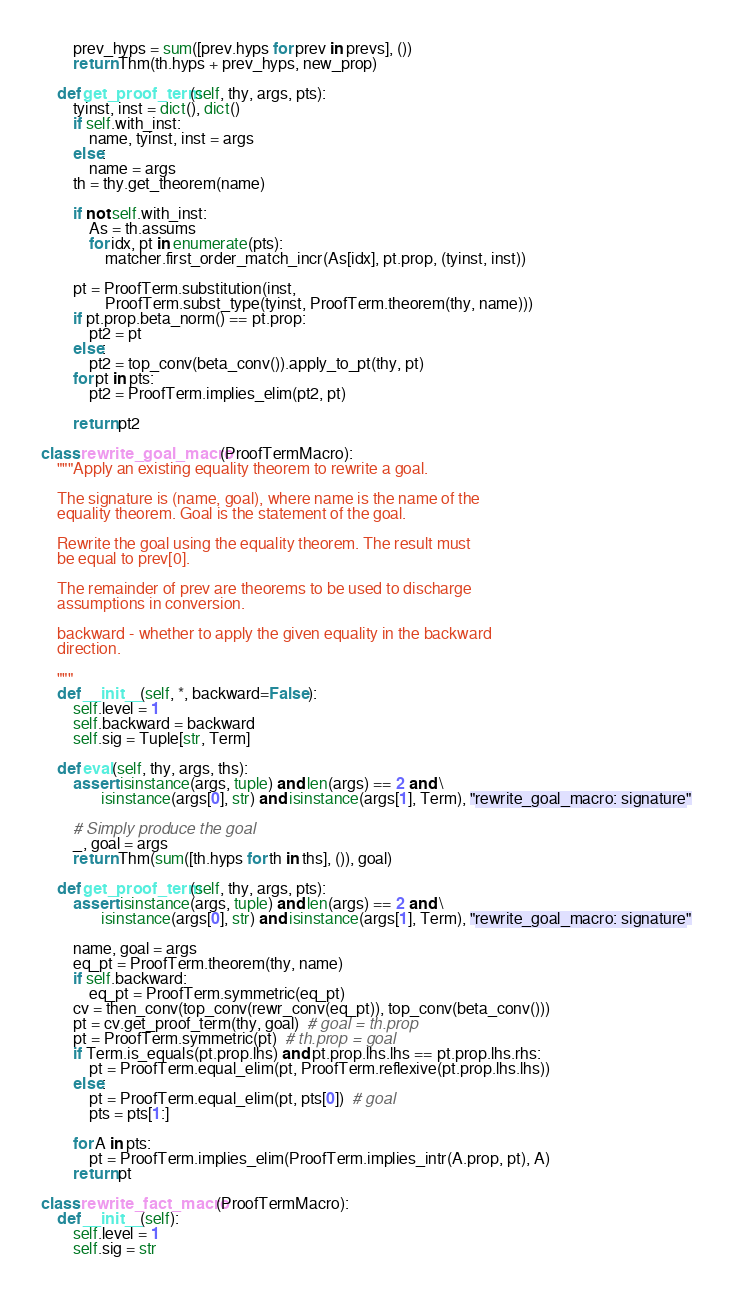Convert code to text. <code><loc_0><loc_0><loc_500><loc_500><_Python_>        prev_hyps = sum([prev.hyps for prev in prevs], ())
        return Thm(th.hyps + prev_hyps, new_prop)

    def get_proof_term(self, thy, args, pts):
        tyinst, inst = dict(), dict()
        if self.with_inst:
            name, tyinst, inst = args
        else:
            name = args
        th = thy.get_theorem(name)

        if not self.with_inst:
            As = th.assums
            for idx, pt in enumerate(pts):
                matcher.first_order_match_incr(As[idx], pt.prop, (tyinst, inst))

        pt = ProofTerm.substitution(inst,
                ProofTerm.subst_type(tyinst, ProofTerm.theorem(thy, name)))
        if pt.prop.beta_norm() == pt.prop:
            pt2 = pt
        else:
            pt2 = top_conv(beta_conv()).apply_to_pt(thy, pt)
        for pt in pts:
            pt2 = ProofTerm.implies_elim(pt2, pt)

        return pt2

class rewrite_goal_macro(ProofTermMacro):
    """Apply an existing equality theorem to rewrite a goal.

    The signature is (name, goal), where name is the name of the
    equality theorem. Goal is the statement of the goal.

    Rewrite the goal using the equality theorem. The result must
    be equal to prev[0].

    The remainder of prev are theorems to be used to discharge
    assumptions in conversion.
    
    backward - whether to apply the given equality in the backward
    direction.

    """
    def __init__(self, *, backward=False):
        self.level = 1
        self.backward = backward
        self.sig = Tuple[str, Term]

    def eval(self, thy, args, ths):
        assert isinstance(args, tuple) and len(args) == 2 and \
               isinstance(args[0], str) and isinstance(args[1], Term), "rewrite_goal_macro: signature"

        # Simply produce the goal
        _, goal = args
        return Thm(sum([th.hyps for th in ths], ()), goal)

    def get_proof_term(self, thy, args, pts):
        assert isinstance(args, tuple) and len(args) == 2 and \
               isinstance(args[0], str) and isinstance(args[1], Term), "rewrite_goal_macro: signature"

        name, goal = args
        eq_pt = ProofTerm.theorem(thy, name)
        if self.backward:
            eq_pt = ProofTerm.symmetric(eq_pt)
        cv = then_conv(top_conv(rewr_conv(eq_pt)), top_conv(beta_conv()))
        pt = cv.get_proof_term(thy, goal)  # goal = th.prop
        pt = ProofTerm.symmetric(pt)  # th.prop = goal
        if Term.is_equals(pt.prop.lhs) and pt.prop.lhs.lhs == pt.prop.lhs.rhs:
            pt = ProofTerm.equal_elim(pt, ProofTerm.reflexive(pt.prop.lhs.lhs))
        else:
            pt = ProofTerm.equal_elim(pt, pts[0])  # goal
            pts = pts[1:]

        for A in pts:
            pt = ProofTerm.implies_elim(ProofTerm.implies_intr(A.prop, pt), A)
        return pt

class rewrite_fact_macro(ProofTermMacro):
    def __init__(self):
        self.level = 1
        self.sig = str
</code> 